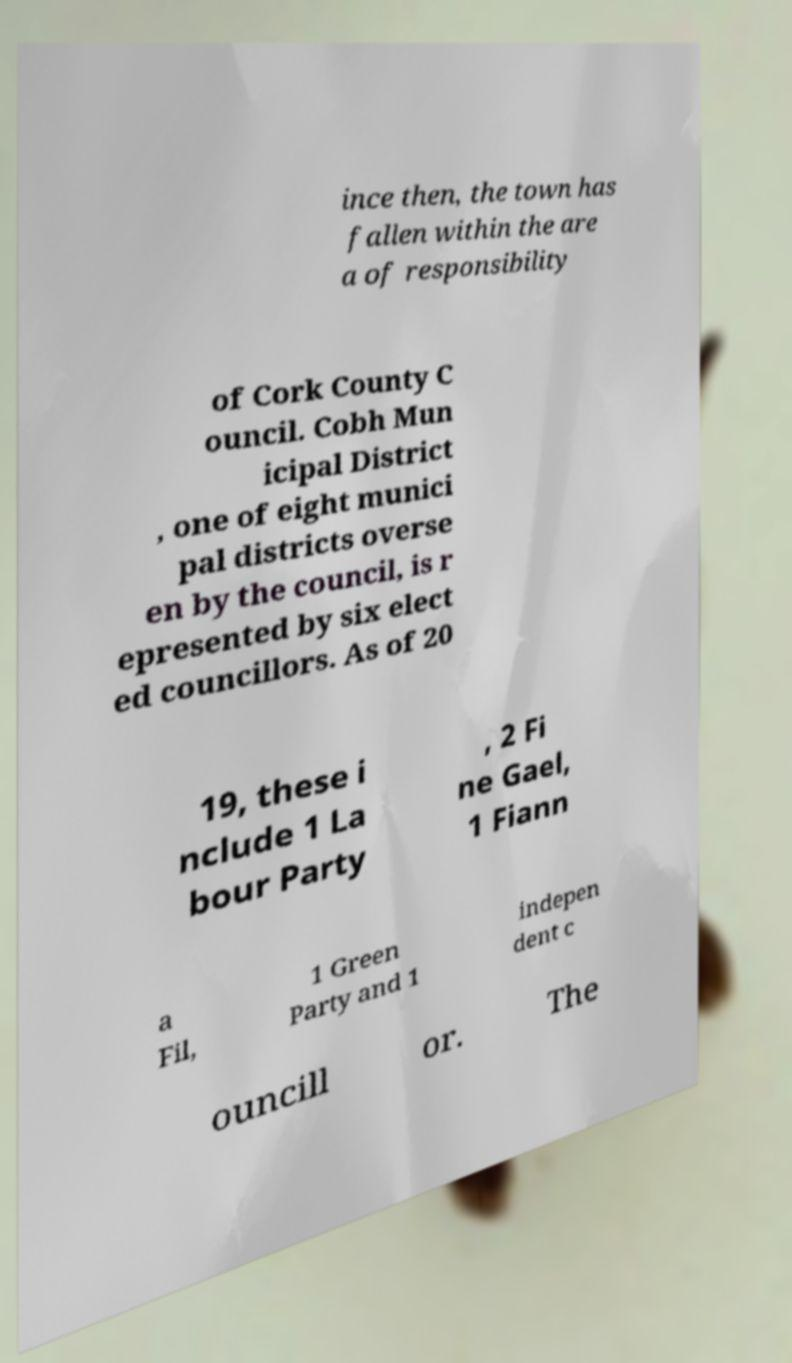There's text embedded in this image that I need extracted. Can you transcribe it verbatim? ince then, the town has fallen within the are a of responsibility of Cork County C ouncil. Cobh Mun icipal District , one of eight munici pal districts overse en by the council, is r epresented by six elect ed councillors. As of 20 19, these i nclude 1 La bour Party , 2 Fi ne Gael, 1 Fiann a Fil, 1 Green Party and 1 indepen dent c ouncill or. The 